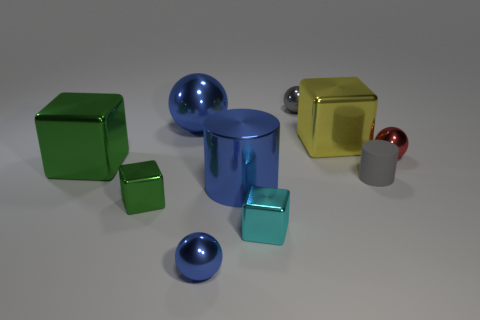Subtract all gray shiny balls. How many balls are left? 3 Subtract all balls. How many objects are left? 6 Subtract all gray cylinders. How many cylinders are left? 1 Subtract all cylinders. Subtract all matte spheres. How many objects are left? 8 Add 7 gray shiny things. How many gray shiny things are left? 8 Add 2 large yellow cubes. How many large yellow cubes exist? 3 Subtract 1 green cubes. How many objects are left? 9 Subtract 2 cylinders. How many cylinders are left? 0 Subtract all gray cubes. Subtract all blue cylinders. How many cubes are left? 4 Subtract all cyan cylinders. How many red spheres are left? 1 